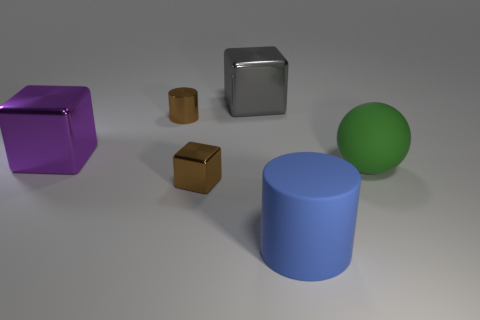There is another large thing that is the same material as the large blue object; what is its shape?
Keep it short and to the point. Sphere. What number of small objects are either gray things or brown metal things?
Provide a succinct answer. 2. Is the number of large blue cylinders greater than the number of small cyan cubes?
Ensure brevity in your answer.  Yes. Are the large gray object and the blue thing made of the same material?
Provide a short and direct response. No. Is the number of tiny things that are behind the big green object greater than the number of purple metallic balls?
Offer a terse response. Yes. Is the color of the tiny metallic cylinder the same as the tiny metallic cube?
Provide a succinct answer. Yes. What number of other metallic things have the same shape as the purple metallic object?
Provide a succinct answer. 2. What is the size of the blue thing that is the same material as the ball?
Your response must be concise. Large. The cube that is behind the rubber sphere and on the right side of the big purple block is what color?
Give a very brief answer. Gray. How many brown objects are the same size as the brown shiny cylinder?
Ensure brevity in your answer.  1. 